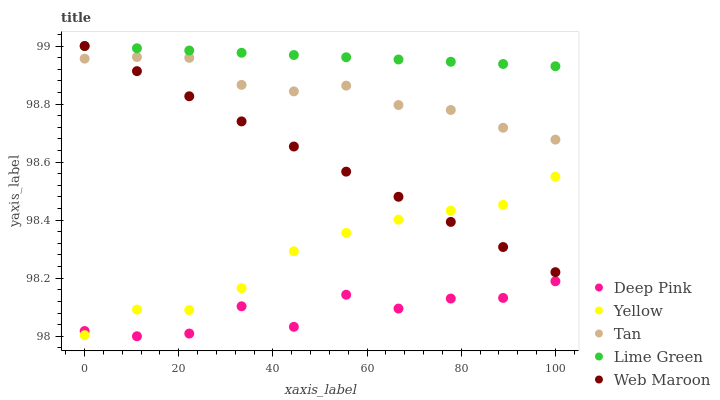Does Deep Pink have the minimum area under the curve?
Answer yes or no. Yes. Does Lime Green have the maximum area under the curve?
Answer yes or no. Yes. Does Tan have the minimum area under the curve?
Answer yes or no. No. Does Tan have the maximum area under the curve?
Answer yes or no. No. Is Web Maroon the smoothest?
Answer yes or no. Yes. Is Deep Pink the roughest?
Answer yes or no. Yes. Is Tan the smoothest?
Answer yes or no. No. Is Tan the roughest?
Answer yes or no. No. Does Deep Pink have the lowest value?
Answer yes or no. Yes. Does Tan have the lowest value?
Answer yes or no. No. Does Lime Green have the highest value?
Answer yes or no. Yes. Does Tan have the highest value?
Answer yes or no. No. Is Deep Pink less than Tan?
Answer yes or no. Yes. Is Lime Green greater than Tan?
Answer yes or no. Yes. Does Yellow intersect Web Maroon?
Answer yes or no. Yes. Is Yellow less than Web Maroon?
Answer yes or no. No. Is Yellow greater than Web Maroon?
Answer yes or no. No. Does Deep Pink intersect Tan?
Answer yes or no. No. 